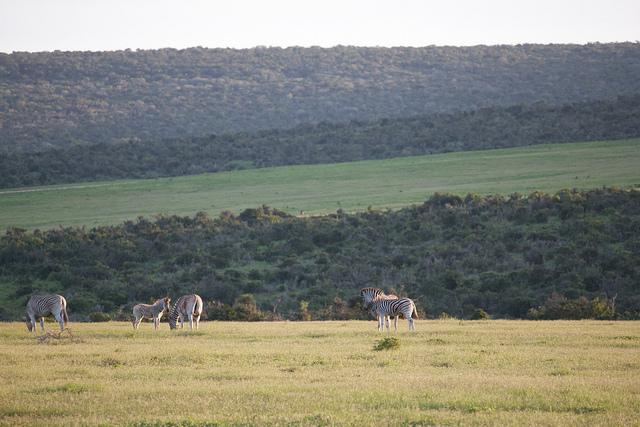What are the zebras looking at on the grass? Please explain your reasoning. food. The zebras are looking down at the grass for food. 